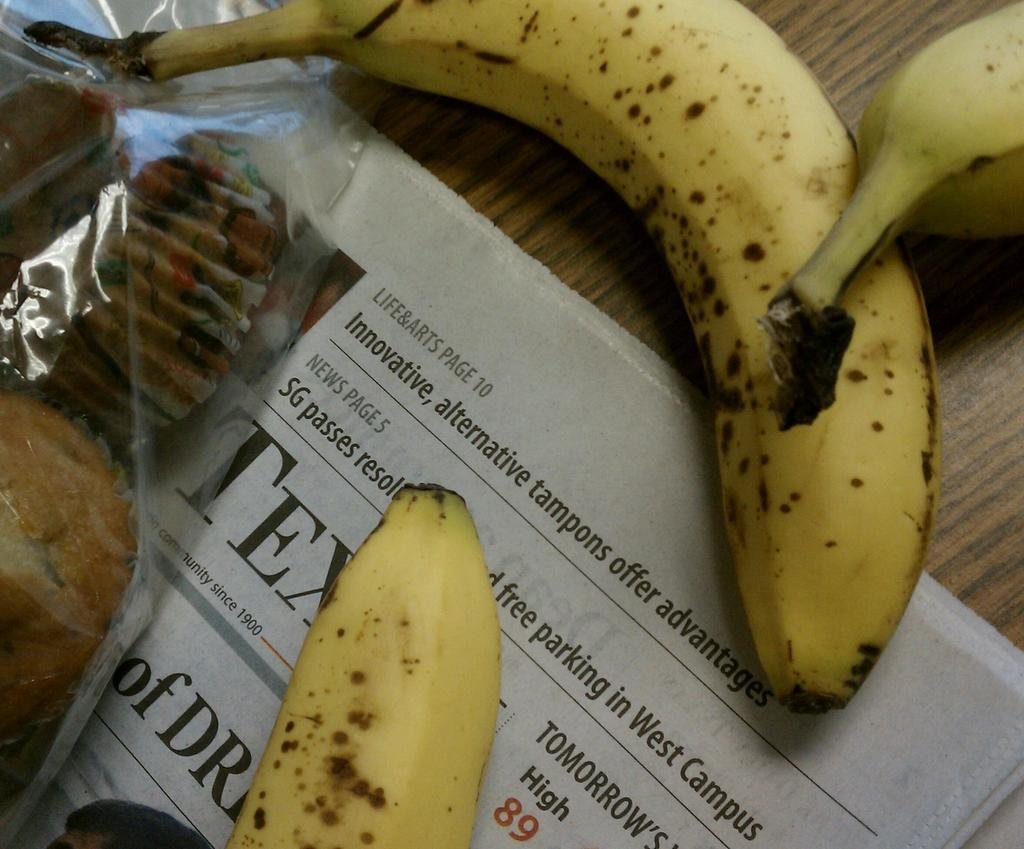What piece of furniture is present in the image? There is a table in the image. What is placed on the table? There is a newspaper and bananas on the table. Are there any baked goods on the table? Yes, there are cupcakes on the table. What type of pocket can be seen on the bananas in the image? There are no pockets on the bananas in the image, as bananas do not have pockets. 